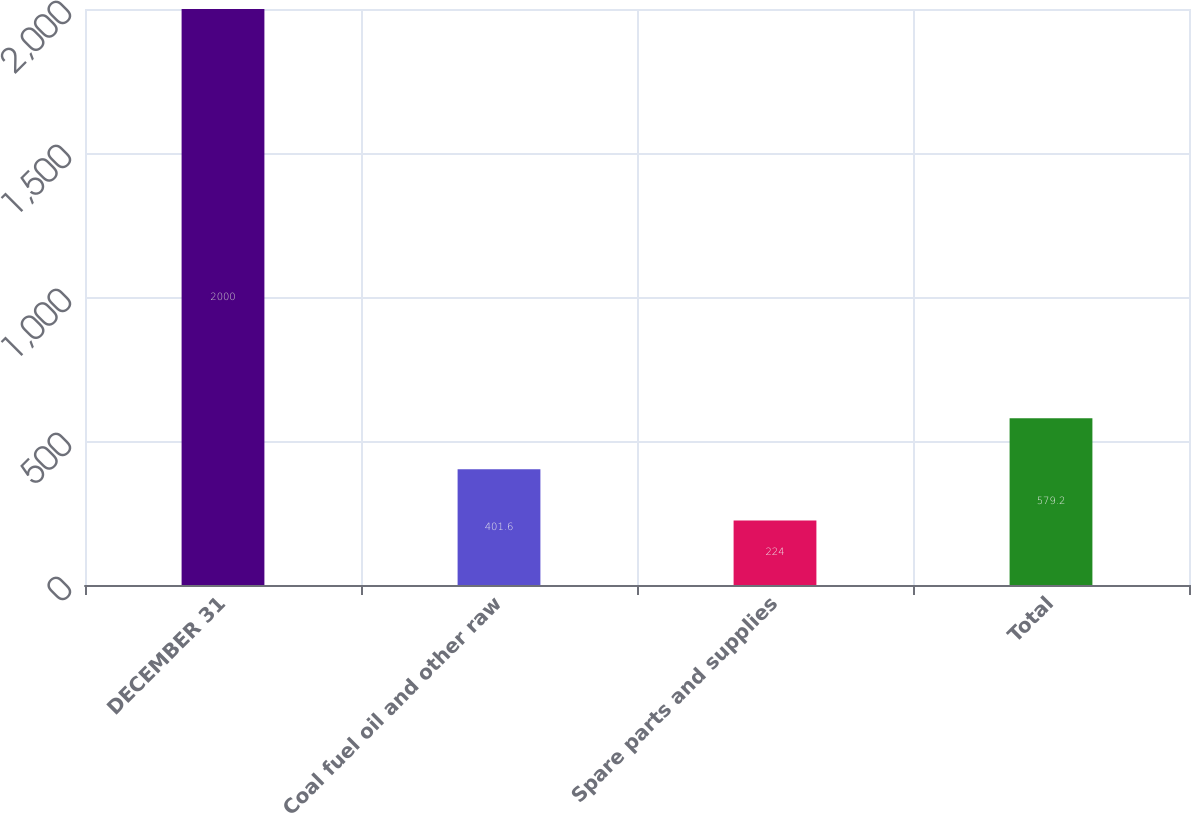Convert chart. <chart><loc_0><loc_0><loc_500><loc_500><bar_chart><fcel>DECEMBER 31<fcel>Coal fuel oil and other raw<fcel>Spare parts and supplies<fcel>Total<nl><fcel>2000<fcel>401.6<fcel>224<fcel>579.2<nl></chart> 